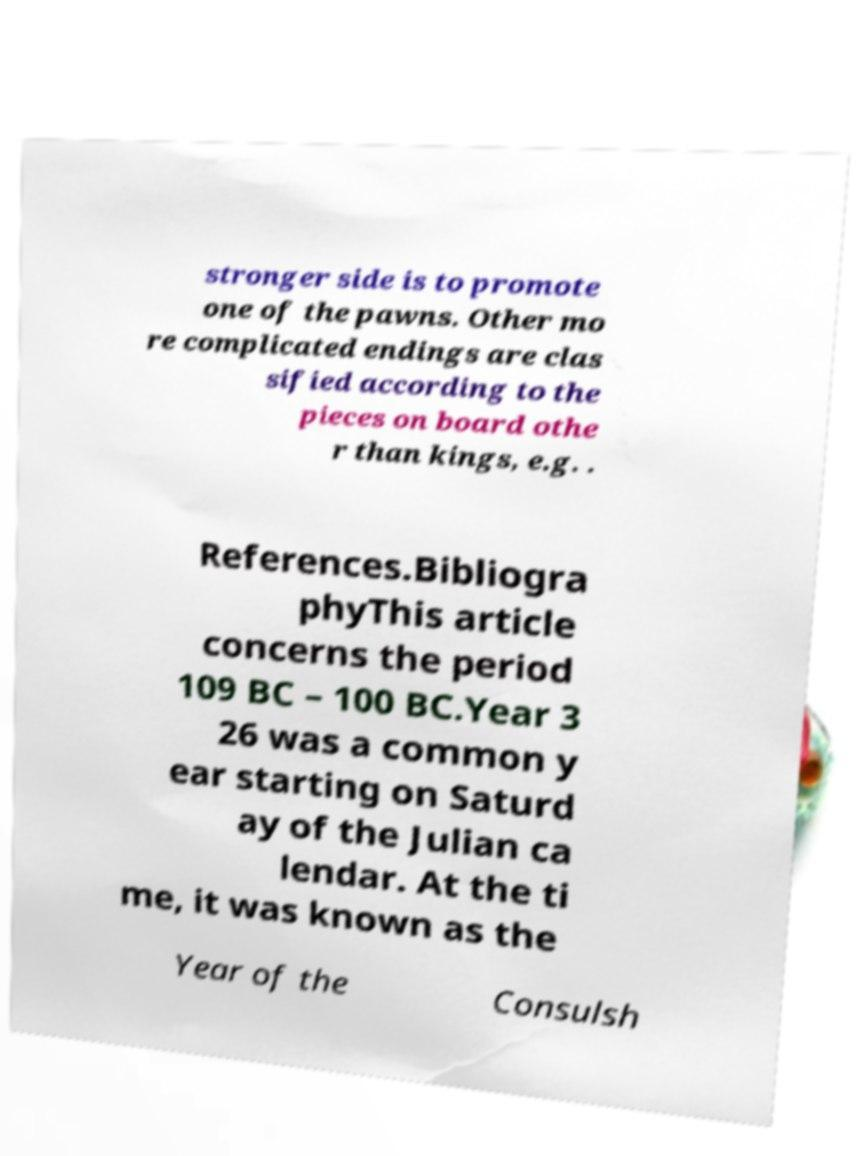Please identify and transcribe the text found in this image. stronger side is to promote one of the pawns. Other mo re complicated endings are clas sified according to the pieces on board othe r than kings, e.g. . References.Bibliogra phyThis article concerns the period 109 BC – 100 BC.Year 3 26 was a common y ear starting on Saturd ay of the Julian ca lendar. At the ti me, it was known as the Year of the Consulsh 